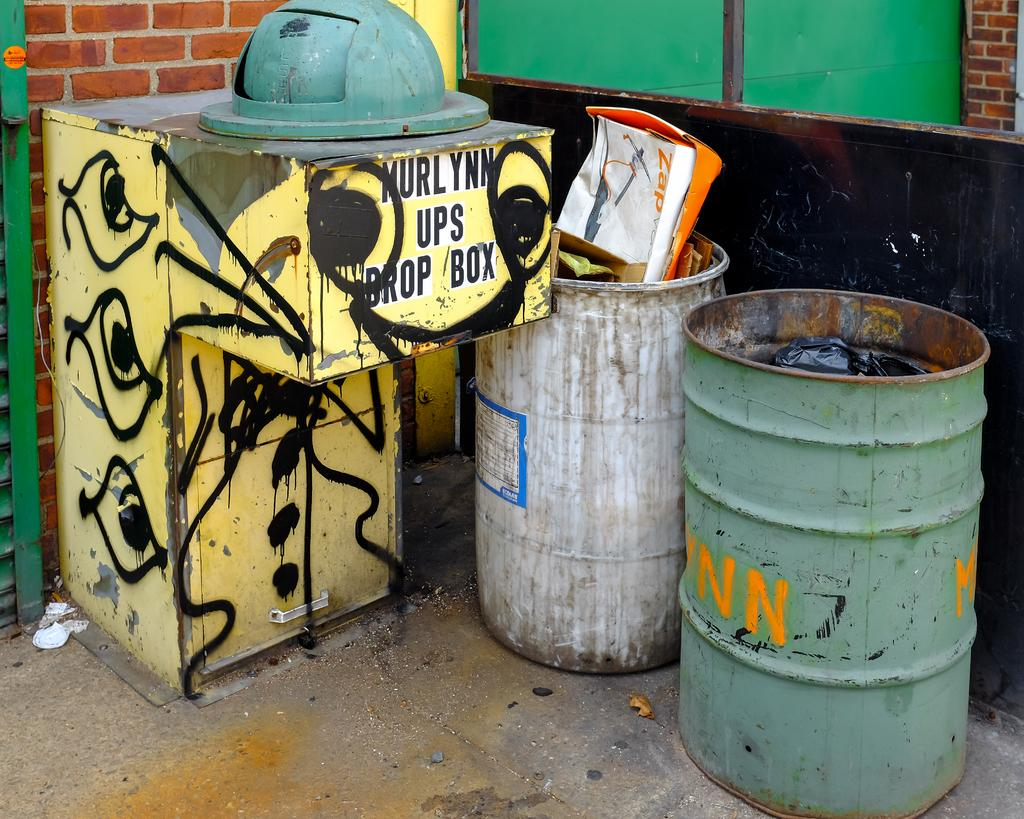Provide a one-sentence caption for the provided image. The Murlynn UPS drop box is sprayed in graffiti. 